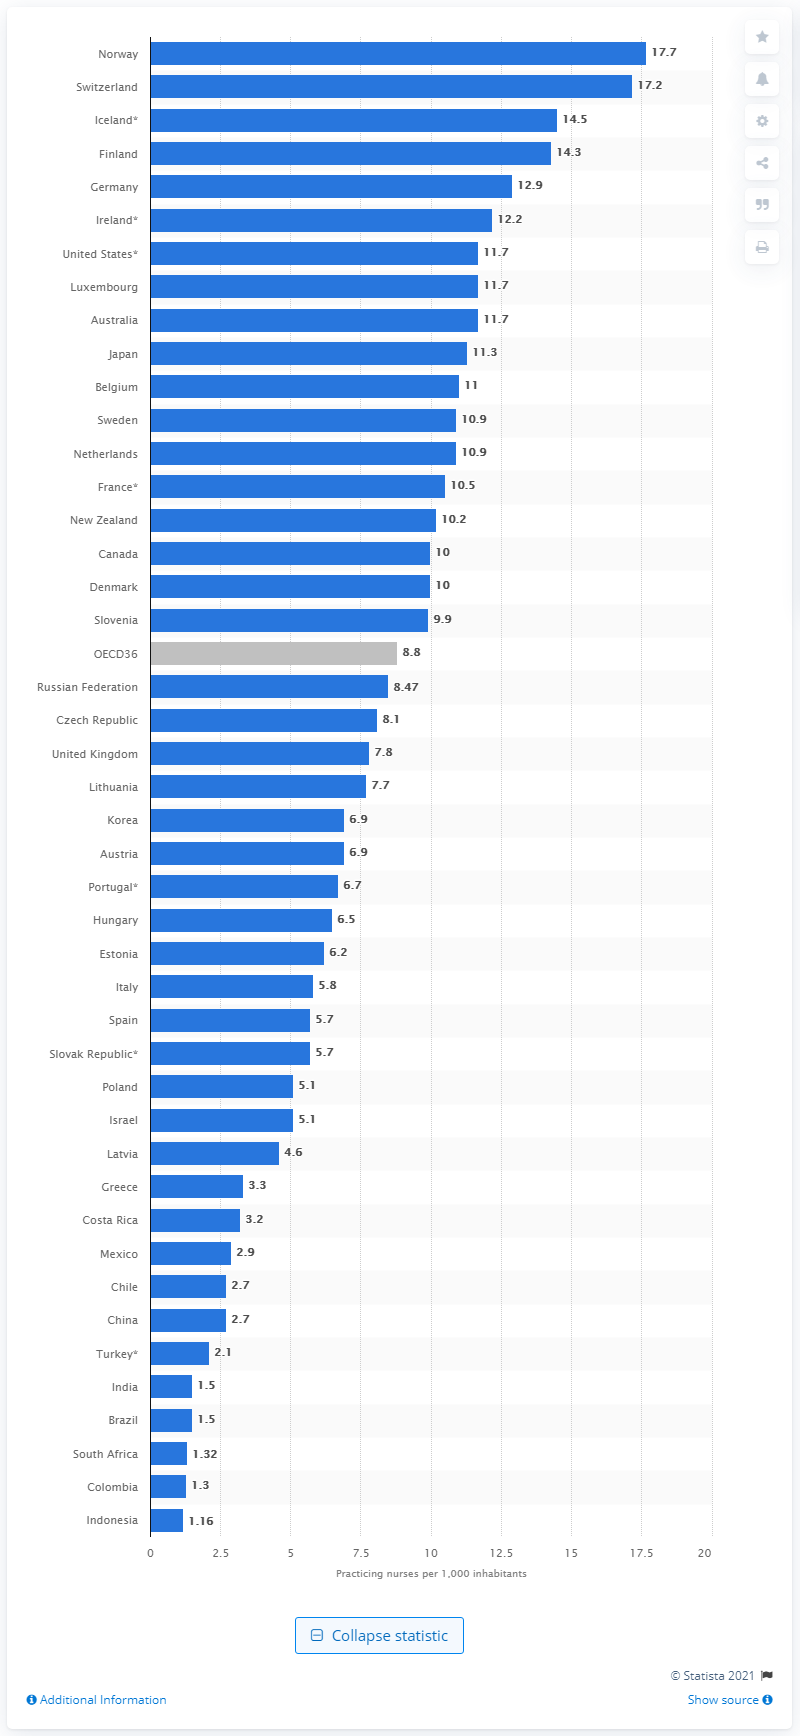Mention a couple of crucial points in this snapshot. As of 2017, there were approximately 17.7 nurses for every 1,000 people in Norway. 